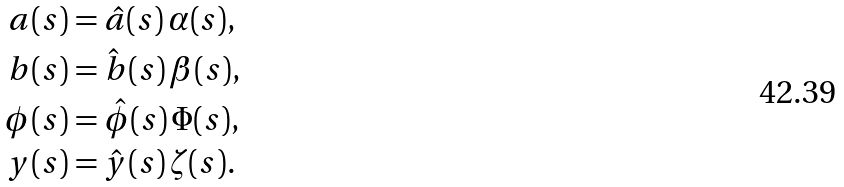<formula> <loc_0><loc_0><loc_500><loc_500>a ( s ) & = \hat { a } ( s ) \, \alpha ( s ) , \\ b ( s ) & = \hat { b } ( s ) \, \beta ( s ) , \\ \phi ( s ) & = \hat { \phi } ( s ) \, \Phi ( s ) , \\ y ( s ) & = \hat { y } ( s ) \, \zeta ( s ) .</formula> 